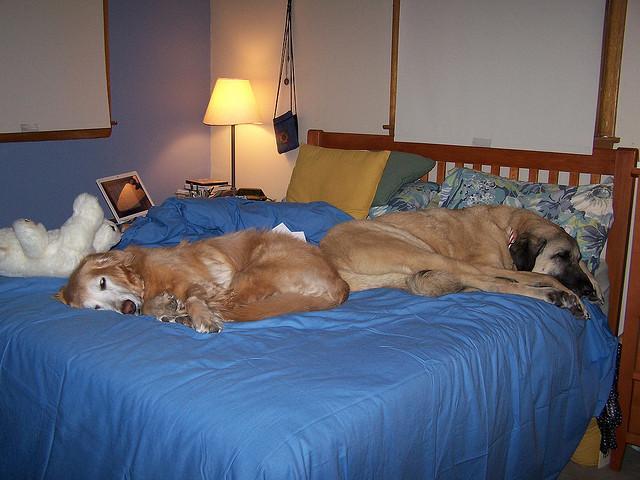How many dogs can be seen?
Give a very brief answer. 2. How many of the remote controls are completely gray?
Give a very brief answer. 0. 